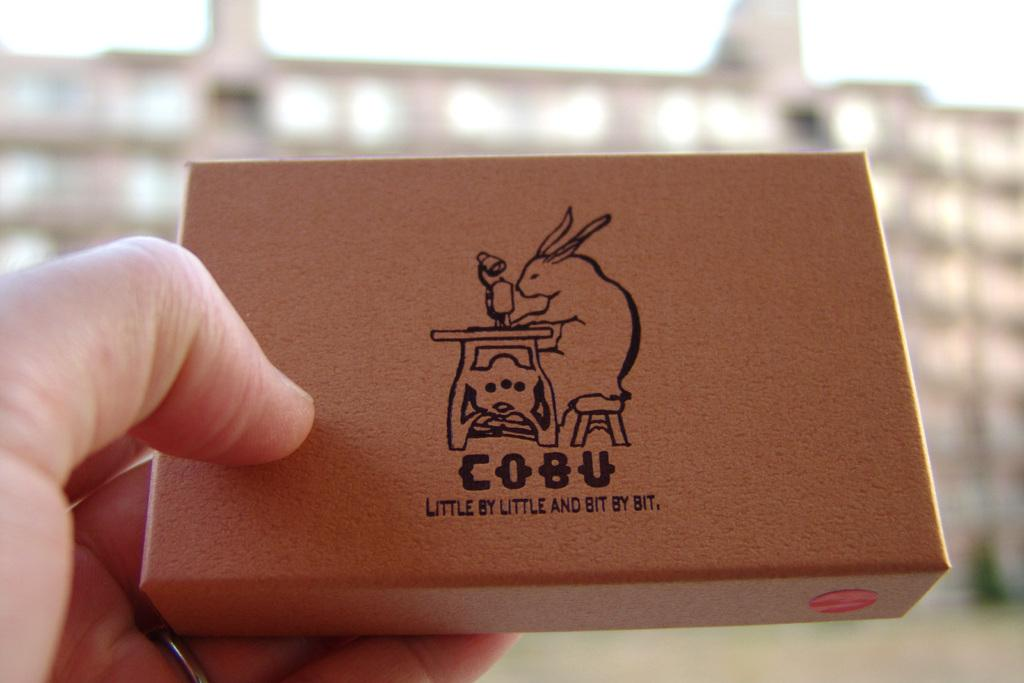<image>
Summarize the visual content of the image. A small box contains the phrase little by little and bit by bit. 